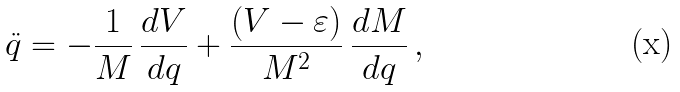Convert formula to latex. <formula><loc_0><loc_0><loc_500><loc_500>\ddot { q } = - \frac { 1 } { M } \, \frac { d V } { d q } + \frac { ( V - \varepsilon ) } { M ^ { 2 } } \, \frac { d M } { d q } \, ,</formula> 